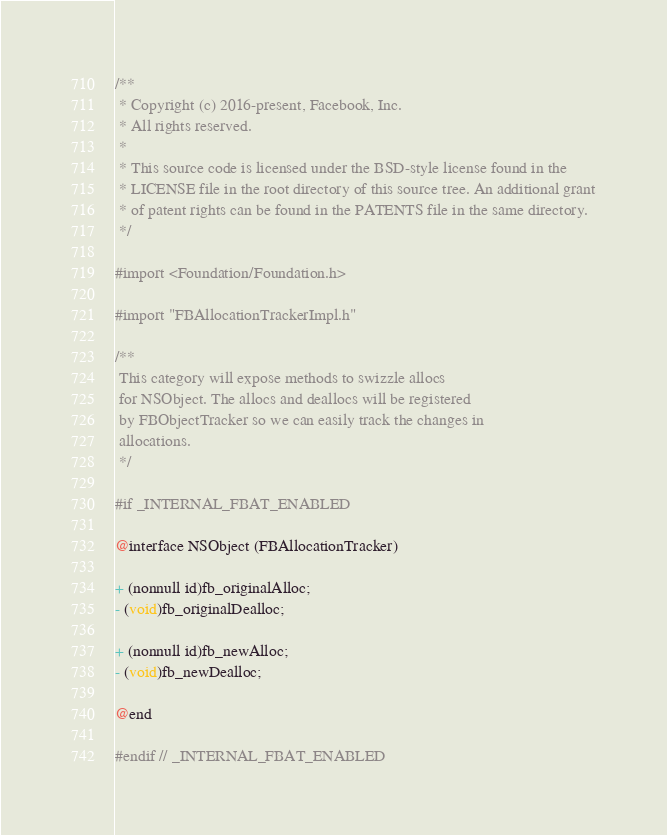<code> <loc_0><loc_0><loc_500><loc_500><_C_>/**
 * Copyright (c) 2016-present, Facebook, Inc.
 * All rights reserved.
 *
 * This source code is licensed under the BSD-style license found in the
 * LICENSE file in the root directory of this source tree. An additional grant
 * of patent rights can be found in the PATENTS file in the same directory.
 */

#import <Foundation/Foundation.h>

#import "FBAllocationTrackerImpl.h"

/**
 This category will expose methods to swizzle allocs
 for NSObject. The allocs and deallocs will be registered
 by FBObjectTracker so we can easily track the changes in
 allocations.
 */

#if _INTERNAL_FBAT_ENABLED

@interface NSObject (FBAllocationTracker)

+ (nonnull id)fb_originalAlloc;
- (void)fb_originalDealloc;

+ (nonnull id)fb_newAlloc;
- (void)fb_newDealloc;

@end

#endif // _INTERNAL_FBAT_ENABLED
</code> 